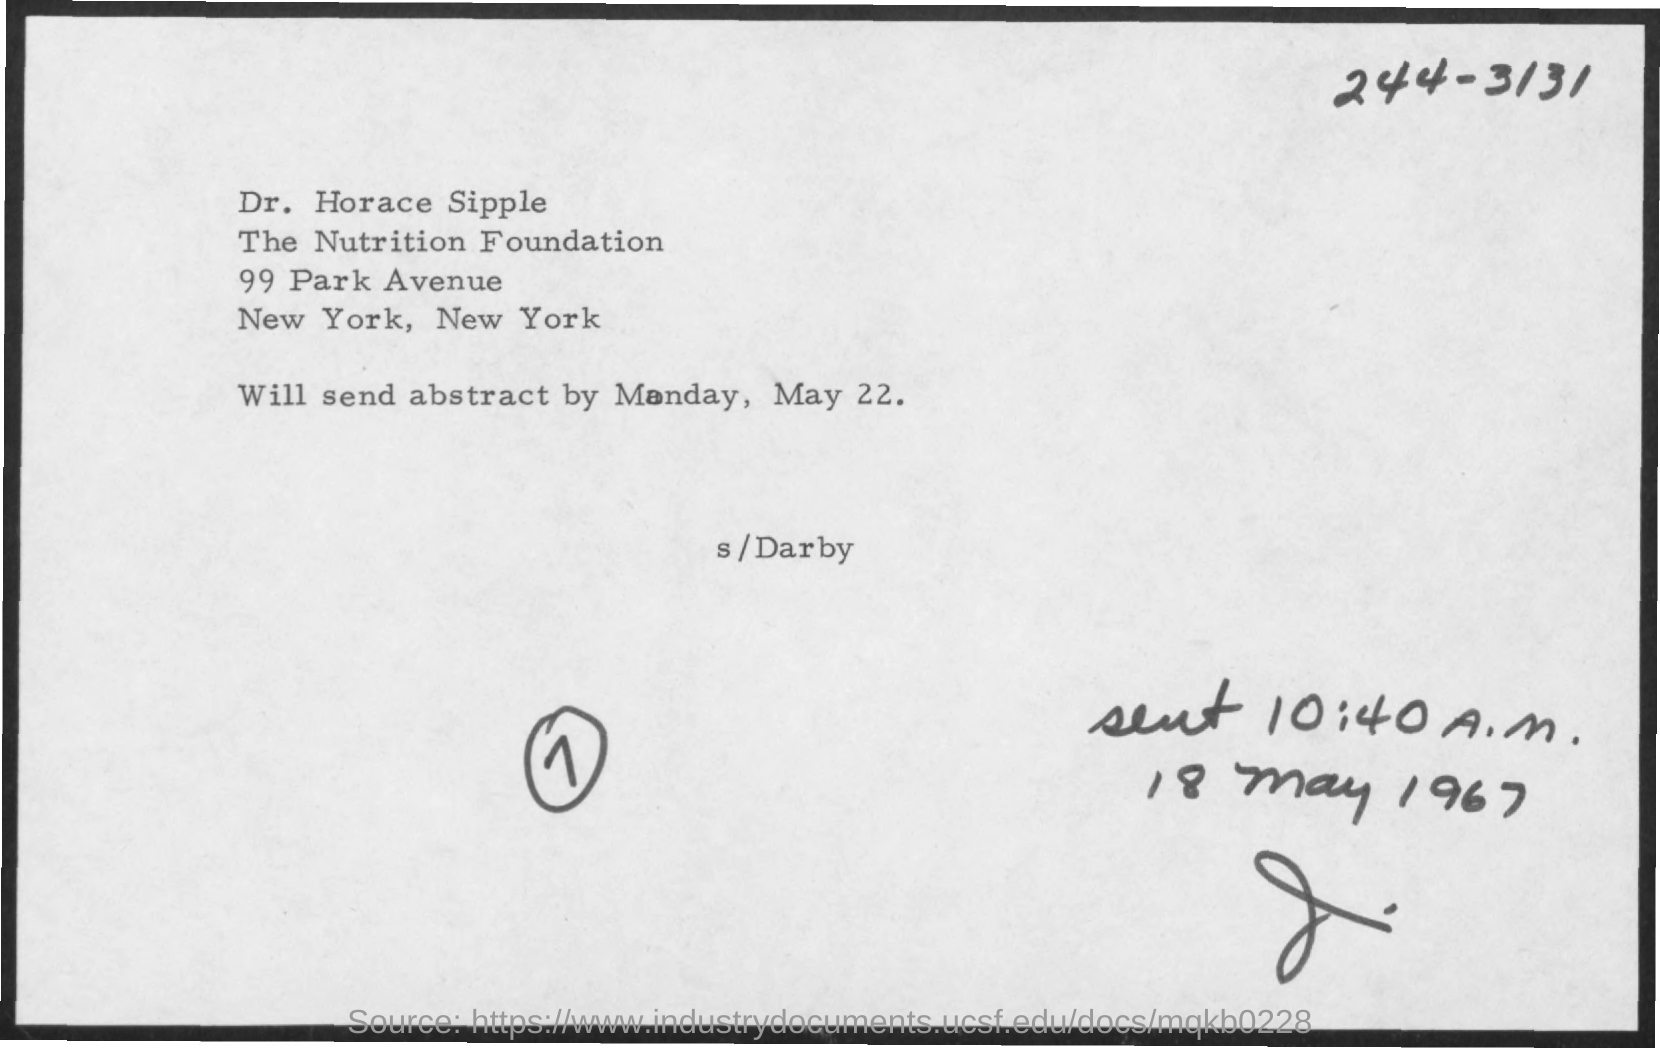On what date will the abstract be sent?
Your answer should be very brief. May 22. What is the sent time mentioned in the document?
Give a very brief answer. Sent 10:40 a. m. To whom, the message is addressed?
Provide a short and direct response. Dr. Horace Sipple. 